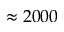Convert formula to latex. <formula><loc_0><loc_0><loc_500><loc_500>\approx 2 0 0 0</formula> 